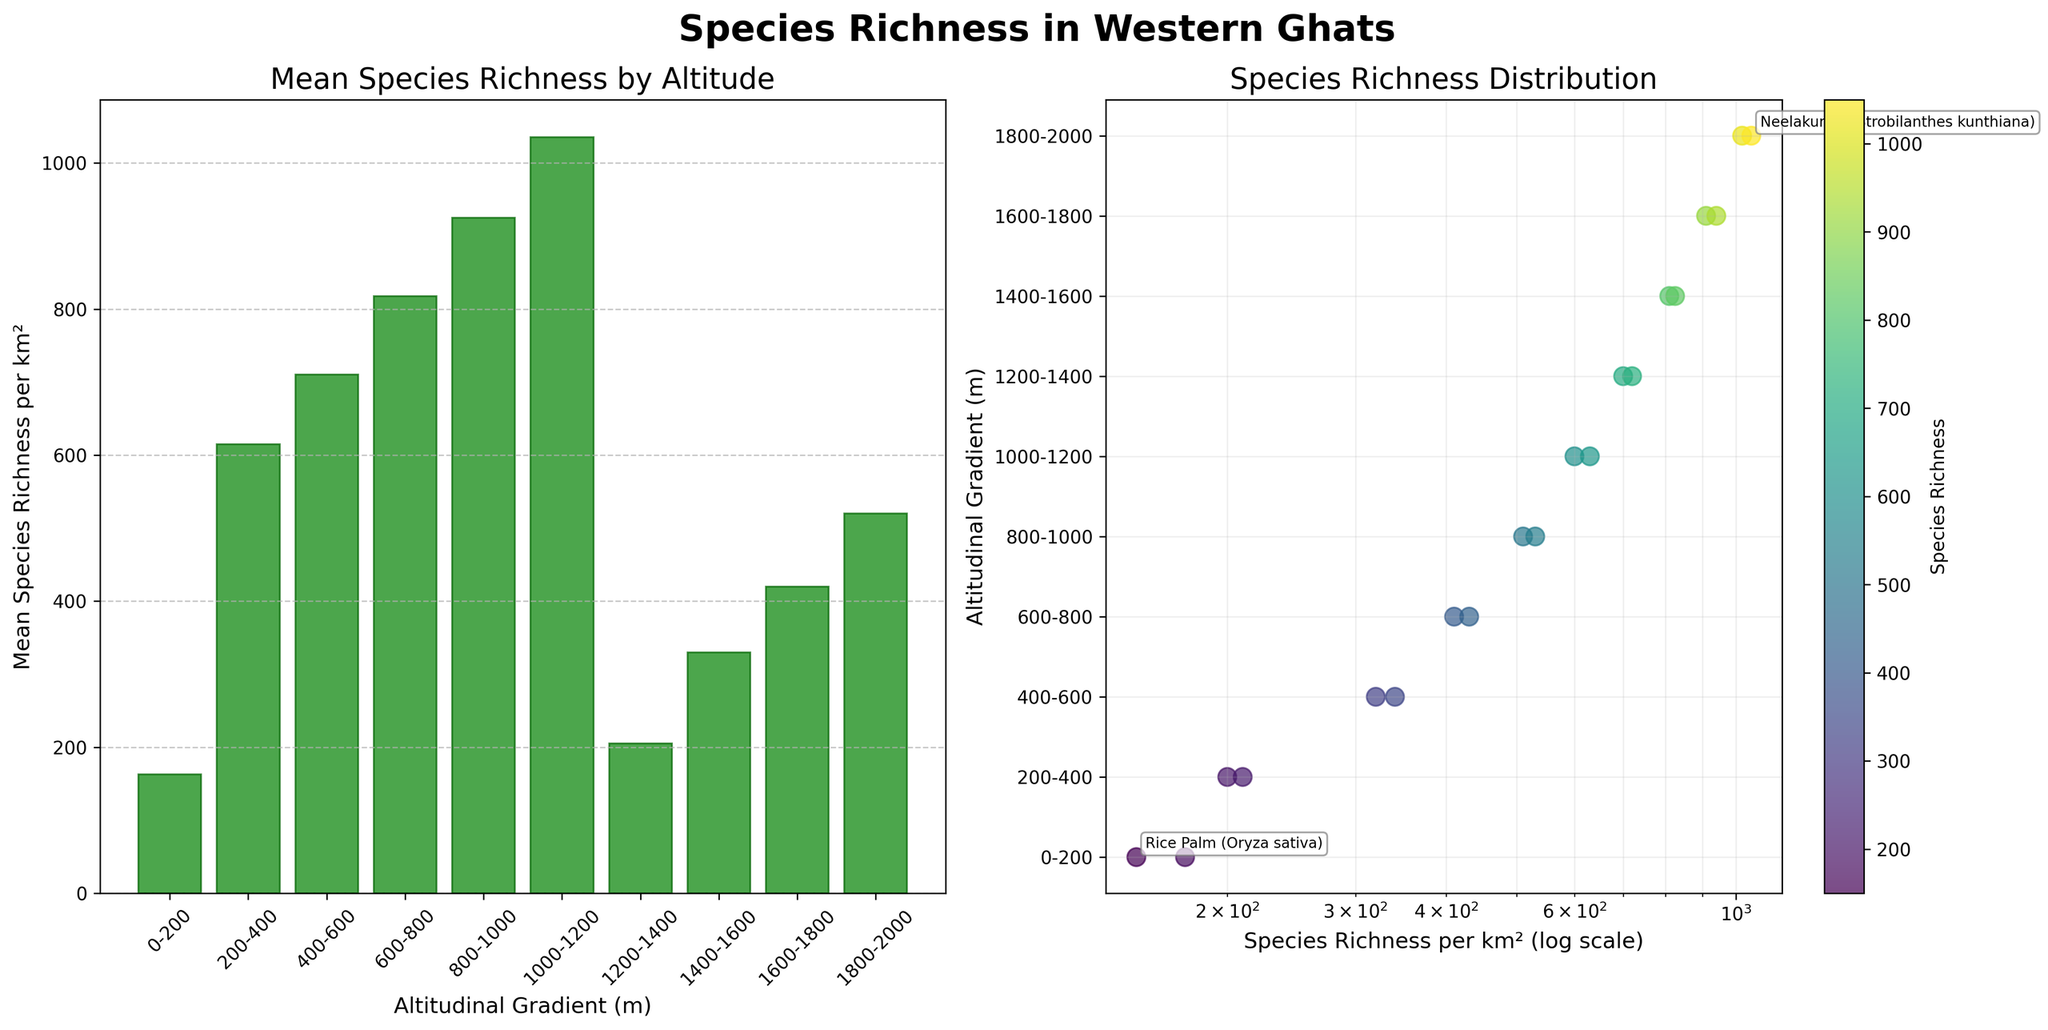Which altitudinal gradient shows the highest mean species richness per km²? The bar plot on the left shows the mean species richness for each altitudinal gradient. The 1800-2000 meters gradient has the highest mean species richness per km² as represented by the tallest bar.
Answer: 1800-2000 meters What is the title of the scatter plot on the right side of the figure? The title is found at the top of the scatter plot on the right side. It is 'Species Richness Distribution'.
Answer: Species Richness Distribution Between which two altitudinal gradients does species richness increase the most? By observing the bar plot, comparing the height of the bars, the most significant increase in mean species richness happens between the 1200-1400 meters and the 1400-1600 meters gradients.
Answer: 1200-1400 and 1400-1600 meters Which two species entities have been annotated in the scatter plot? The scatter plot has two species entities annotated. From the plot, these annotations are visible for Neelakurinji (Strobilanthes kunthiana) and Rice Palm (Oryza sativa).
Answer: Neelakurinji (Strobilanthes kunthiana) and Rice Palm (Oryza sativa) How many distinct altitudinal gradients are shown in the plots? Counting the number of unique categories for altitudes shown on the x-axis of the bar plot, there are ten distinct altitudinal gradients.
Answer: 10 In which altitudinal gradient does the scatter plot show the highest species richness per unit area? In the scatter plot, the point at the highest value on the x-axis (species richness per km²) and its corresponding y-axis (altitudinal gradient) represents the highest species richness. It is in the 1800-2000 meters gradient since the points corresponding to 1020 and 1050 species richness per km² are seen here.
Answer: 1800-2000 meters What effect does plotting species richness on a log scale have in the scatter plot? Using a log scale for species richness x-axis spreads out the lower values and compresses the higher values, making it easier to compare species richness across a wide range.
Answer: Spreads lower values, compresses higher values Is there a general trend of mean species richness per km² as altitude increases based on the bar plot? By observing the heights of bars sequentially from left to right, the general trend is an increase in mean species richness per km² with increasing altitude.
Answer: Increases with altitude What is the color scheme used in the scatter plot for species richness and what does it signify? The color scheme used is from the viridis colormap, where lighter colors represent higher species richness per km² and darker colors represent lower richness.
Answer: Lighter colors = Higher richness, Darker colors = Lower richness 